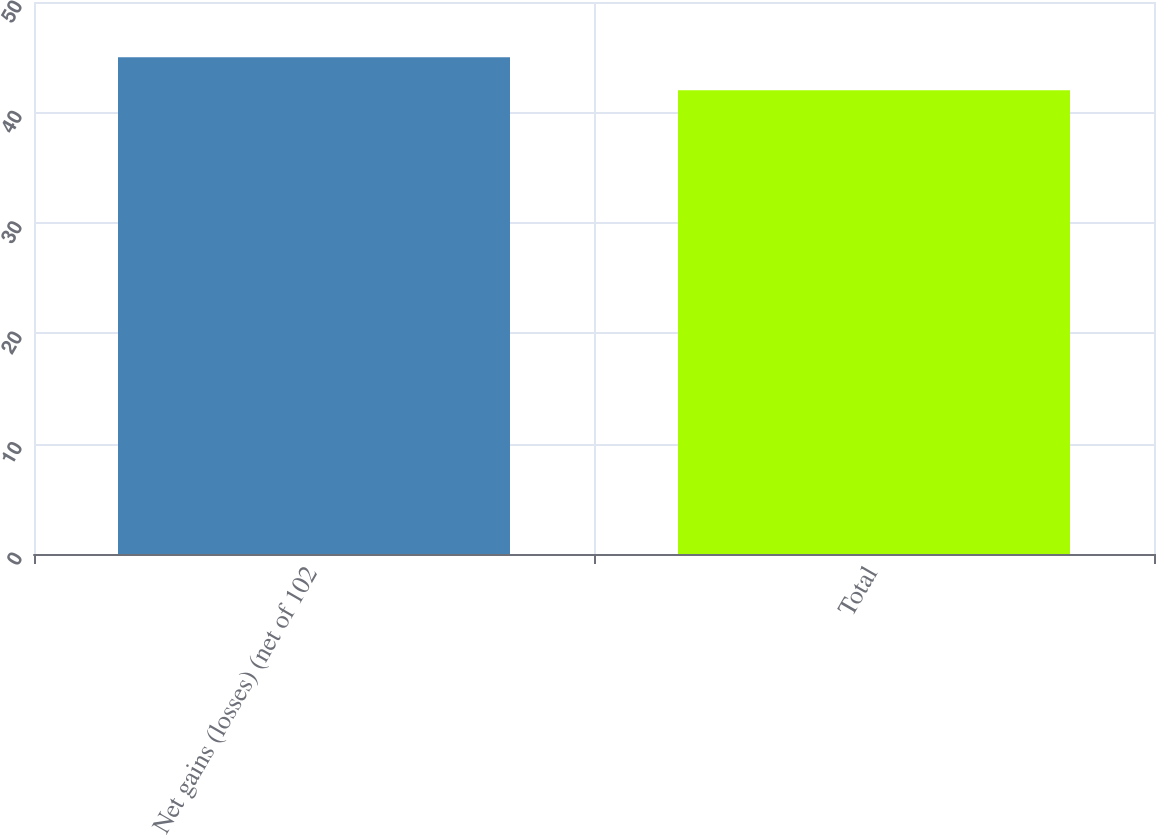<chart> <loc_0><loc_0><loc_500><loc_500><bar_chart><fcel>Net gains (losses) (net of 102<fcel>Total<nl><fcel>45<fcel>42<nl></chart> 